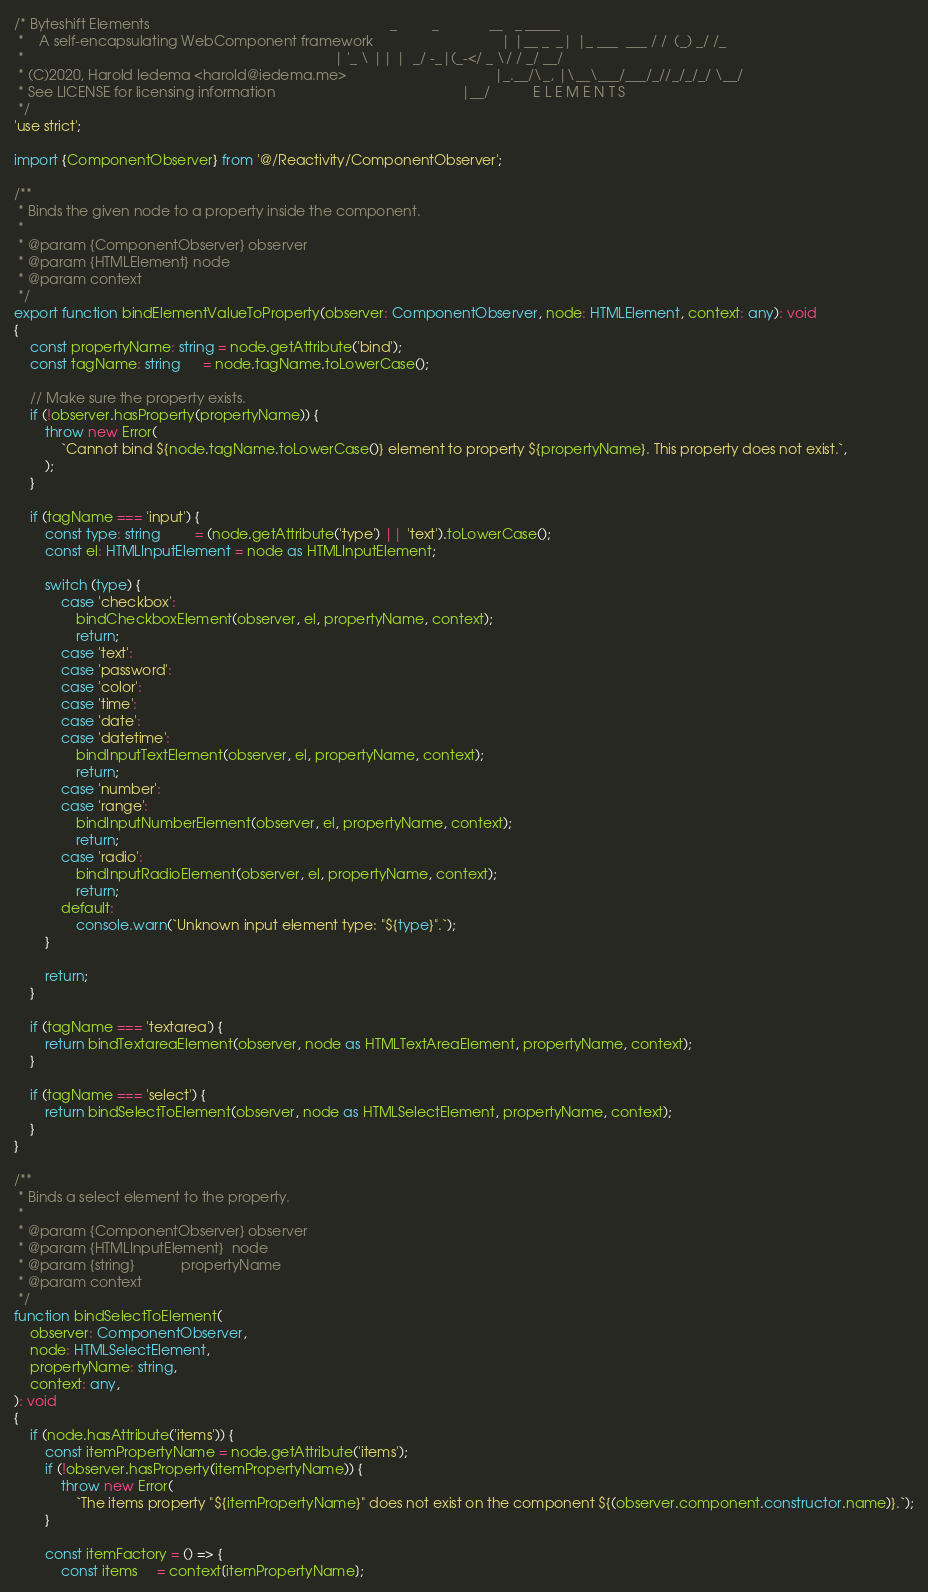Convert code to text. <code><loc_0><loc_0><loc_500><loc_500><_TypeScript_>/* Byteshift Elements                                                              _         _             __   _ _____
 *    A self-encapsulating WebComponent framework                                 | |__ _  _| |_ ___  ___ / /  (_) _/ /_
 *                                                                                | '_ \ || |  _/ -_|(_-</ _ \/ / _/ __/
 * (C)2020, Harold Iedema <harold@iedema.me>                                      |_.__/\_, |\__\___/___/_//_/_/_/ \__/
 * See LICENSE for licensing information                                                |__/           E L E M E N T S
 */
'use strict';

import {ComponentObserver} from '@/Reactivity/ComponentObserver';

/**
 * Binds the given node to a property inside the component.
 *
 * @param {ComponentObserver} observer
 * @param {HTMLElement} node
 * @param context
 */
export function bindElementValueToProperty(observer: ComponentObserver, node: HTMLElement, context: any): void
{
    const propertyName: string = node.getAttribute('bind');
    const tagName: string      = node.tagName.toLowerCase();

    // Make sure the property exists.
    if (!observer.hasProperty(propertyName)) {
        throw new Error(
            `Cannot bind ${node.tagName.toLowerCase()} element to property ${propertyName}. This property does not exist.`,
        );
    }

    if (tagName === 'input') {
        const type: string         = (node.getAttribute('type') || 'text').toLowerCase();
        const el: HTMLInputElement = node as HTMLInputElement;

        switch (type) {
            case 'checkbox':
                bindCheckboxElement(observer, el, propertyName, context);
                return;
            case 'text':
            case 'password':
            case 'color':
            case 'time':
            case 'date':
            case 'datetime':
                bindInputTextElement(observer, el, propertyName, context);
                return;
            case 'number':
            case 'range':
                bindInputNumberElement(observer, el, propertyName, context);
                return;
            case 'radio':
                bindInputRadioElement(observer, el, propertyName, context);
                return;
            default:
                console.warn(`Unknown input element type: "${type}".`);
        }

        return;
    }

    if (tagName === 'textarea') {
        return bindTextareaElement(observer, node as HTMLTextAreaElement, propertyName, context);
    }

    if (tagName === 'select') {
        return bindSelectToElement(observer, node as HTMLSelectElement, propertyName, context);
    }
}

/**
 * Binds a select element to the property.
 *
 * @param {ComponentObserver} observer
 * @param {HTMLInputElement}  node
 * @param {string}            propertyName
 * @param context
 */
function bindSelectToElement(
    observer: ComponentObserver,
    node: HTMLSelectElement,
    propertyName: string,
    context: any,
): void
{
    if (node.hasAttribute('items')) {
        const itemPropertyName = node.getAttribute('items');
        if (!observer.hasProperty(itemPropertyName)) {
            throw new Error(
                `The items property "${itemPropertyName}" does not exist on the component ${(observer.component.constructor.name)}.`);
        }

        const itemFactory = () => {
            const items     = context[itemPropertyName];</code> 